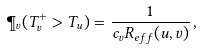Convert formula to latex. <formula><loc_0><loc_0><loc_500><loc_500>\P _ { v } ( T _ { v } ^ { + } > T _ { u } ) = \frac { 1 } { c _ { v } R _ { e f f } ( u , v ) } \, ,</formula> 